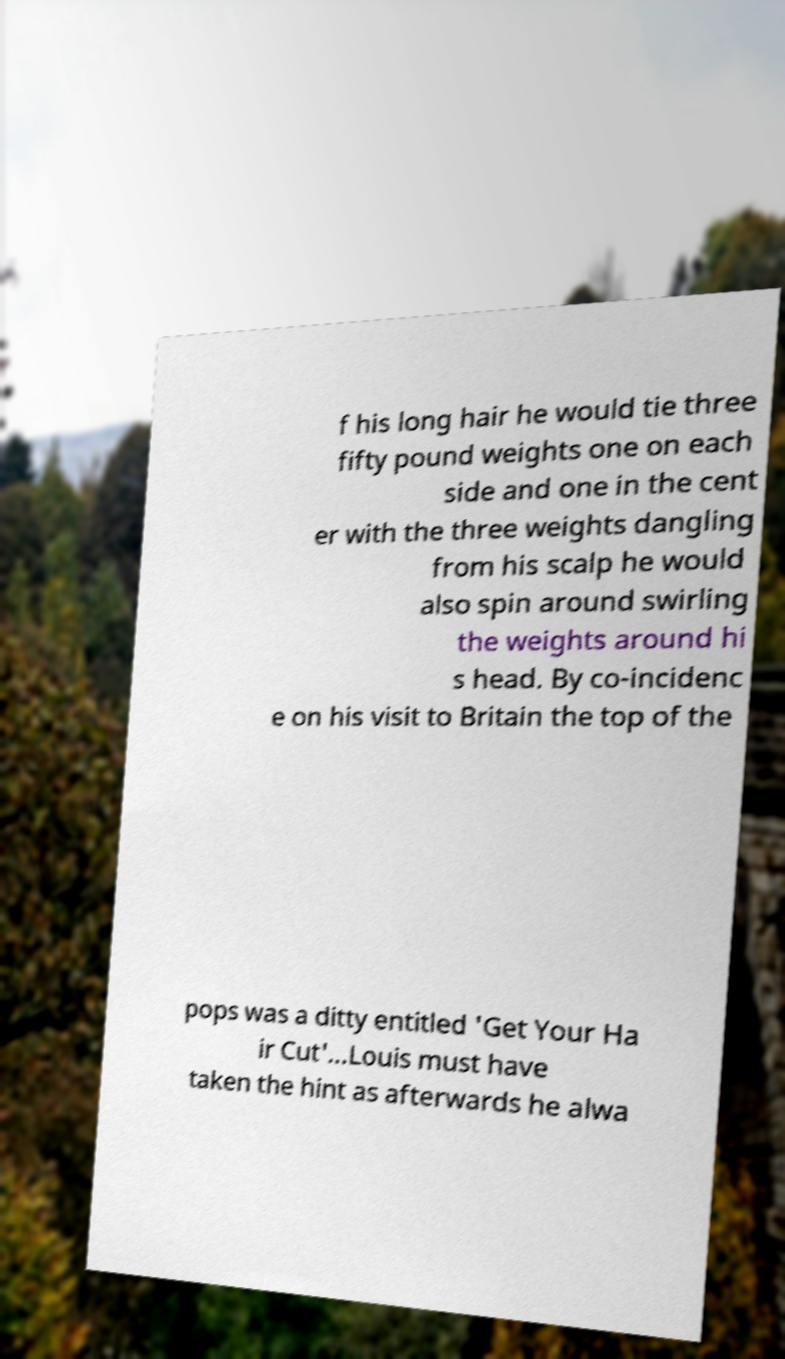Please identify and transcribe the text found in this image. f his long hair he would tie three fifty pound weights one on each side and one in the cent er with the three weights dangling from his scalp he would also spin around swirling the weights around hi s head. By co-incidenc e on his visit to Britain the top of the pops was a ditty entitled 'Get Your Ha ir Cut'...Louis must have taken the hint as afterwards he alwa 